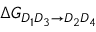<formula> <loc_0><loc_0><loc_500><loc_500>\Delta G _ { D _ { 1 } D _ { 3 } \rightarrow D _ { 2 } D _ { 4 } }</formula> 